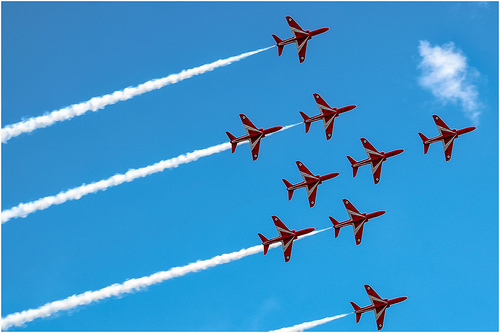<image>
Can you confirm if the exhaust is behind the plane? Yes. From this viewpoint, the exhaust is positioned behind the plane, with the plane partially or fully occluding the exhaust. Where is the plane in relation to the sky? Is it in the sky? Yes. The plane is contained within or inside the sky, showing a containment relationship. 